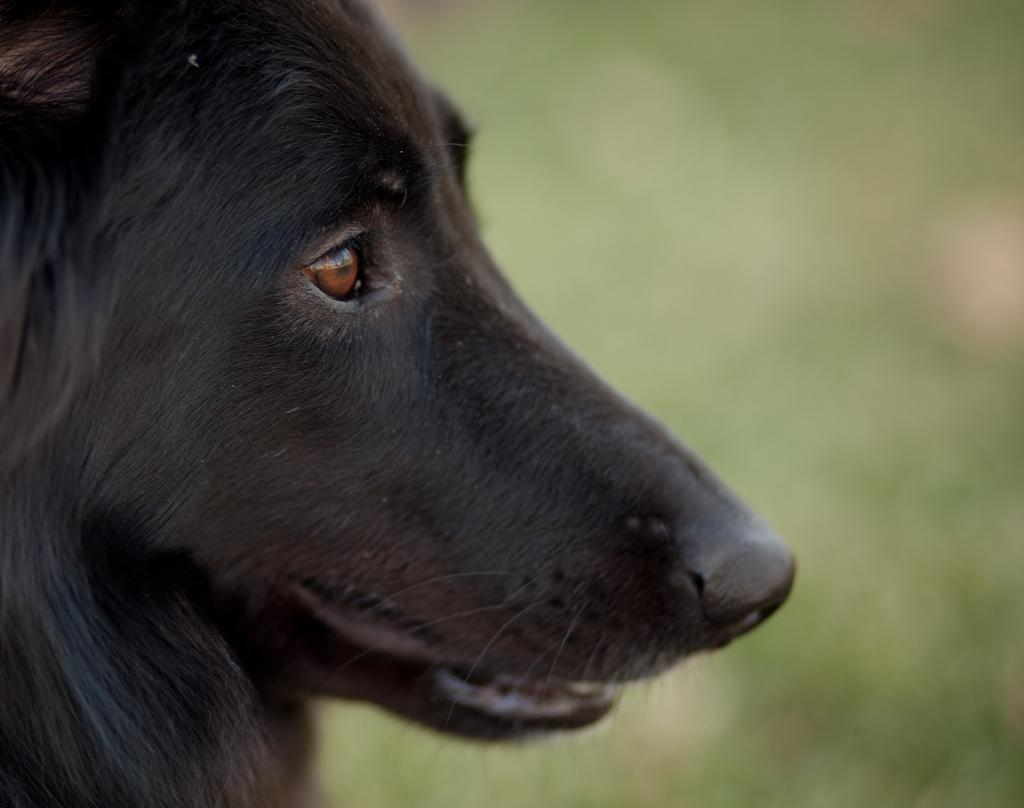What is the main subject of the image? There is a dog face in the front of the image. Can you describe the background of the image? The background of the image is blurry. What type of current can be seen flowing through the scissors in the image? There are no scissors or current present in the image; it features a dog face with a blurry background. 